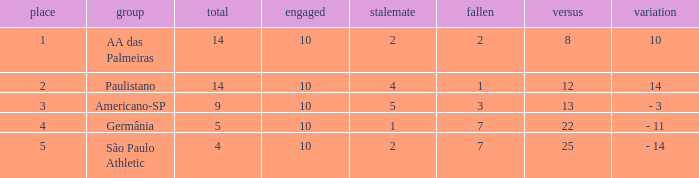What is the against value when the drawn number is 5? 13.0. 